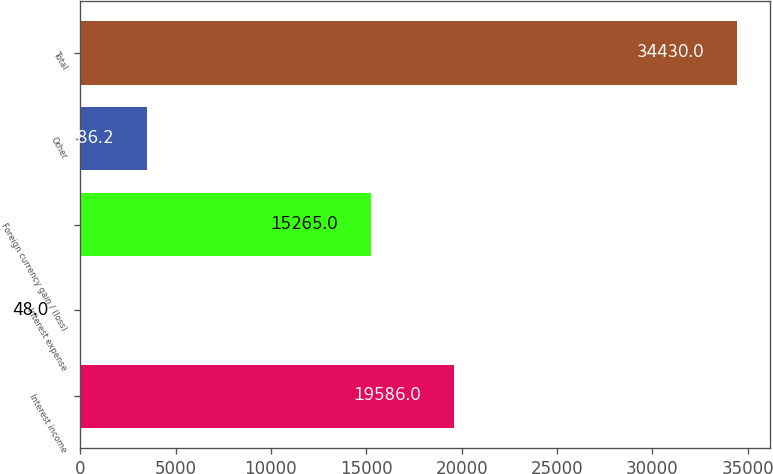<chart> <loc_0><loc_0><loc_500><loc_500><bar_chart><fcel>Interest income<fcel>Interest expense<fcel>Foreign currency gain / (loss)<fcel>Other<fcel>Total<nl><fcel>19586<fcel>48<fcel>15265<fcel>3486.2<fcel>34430<nl></chart> 